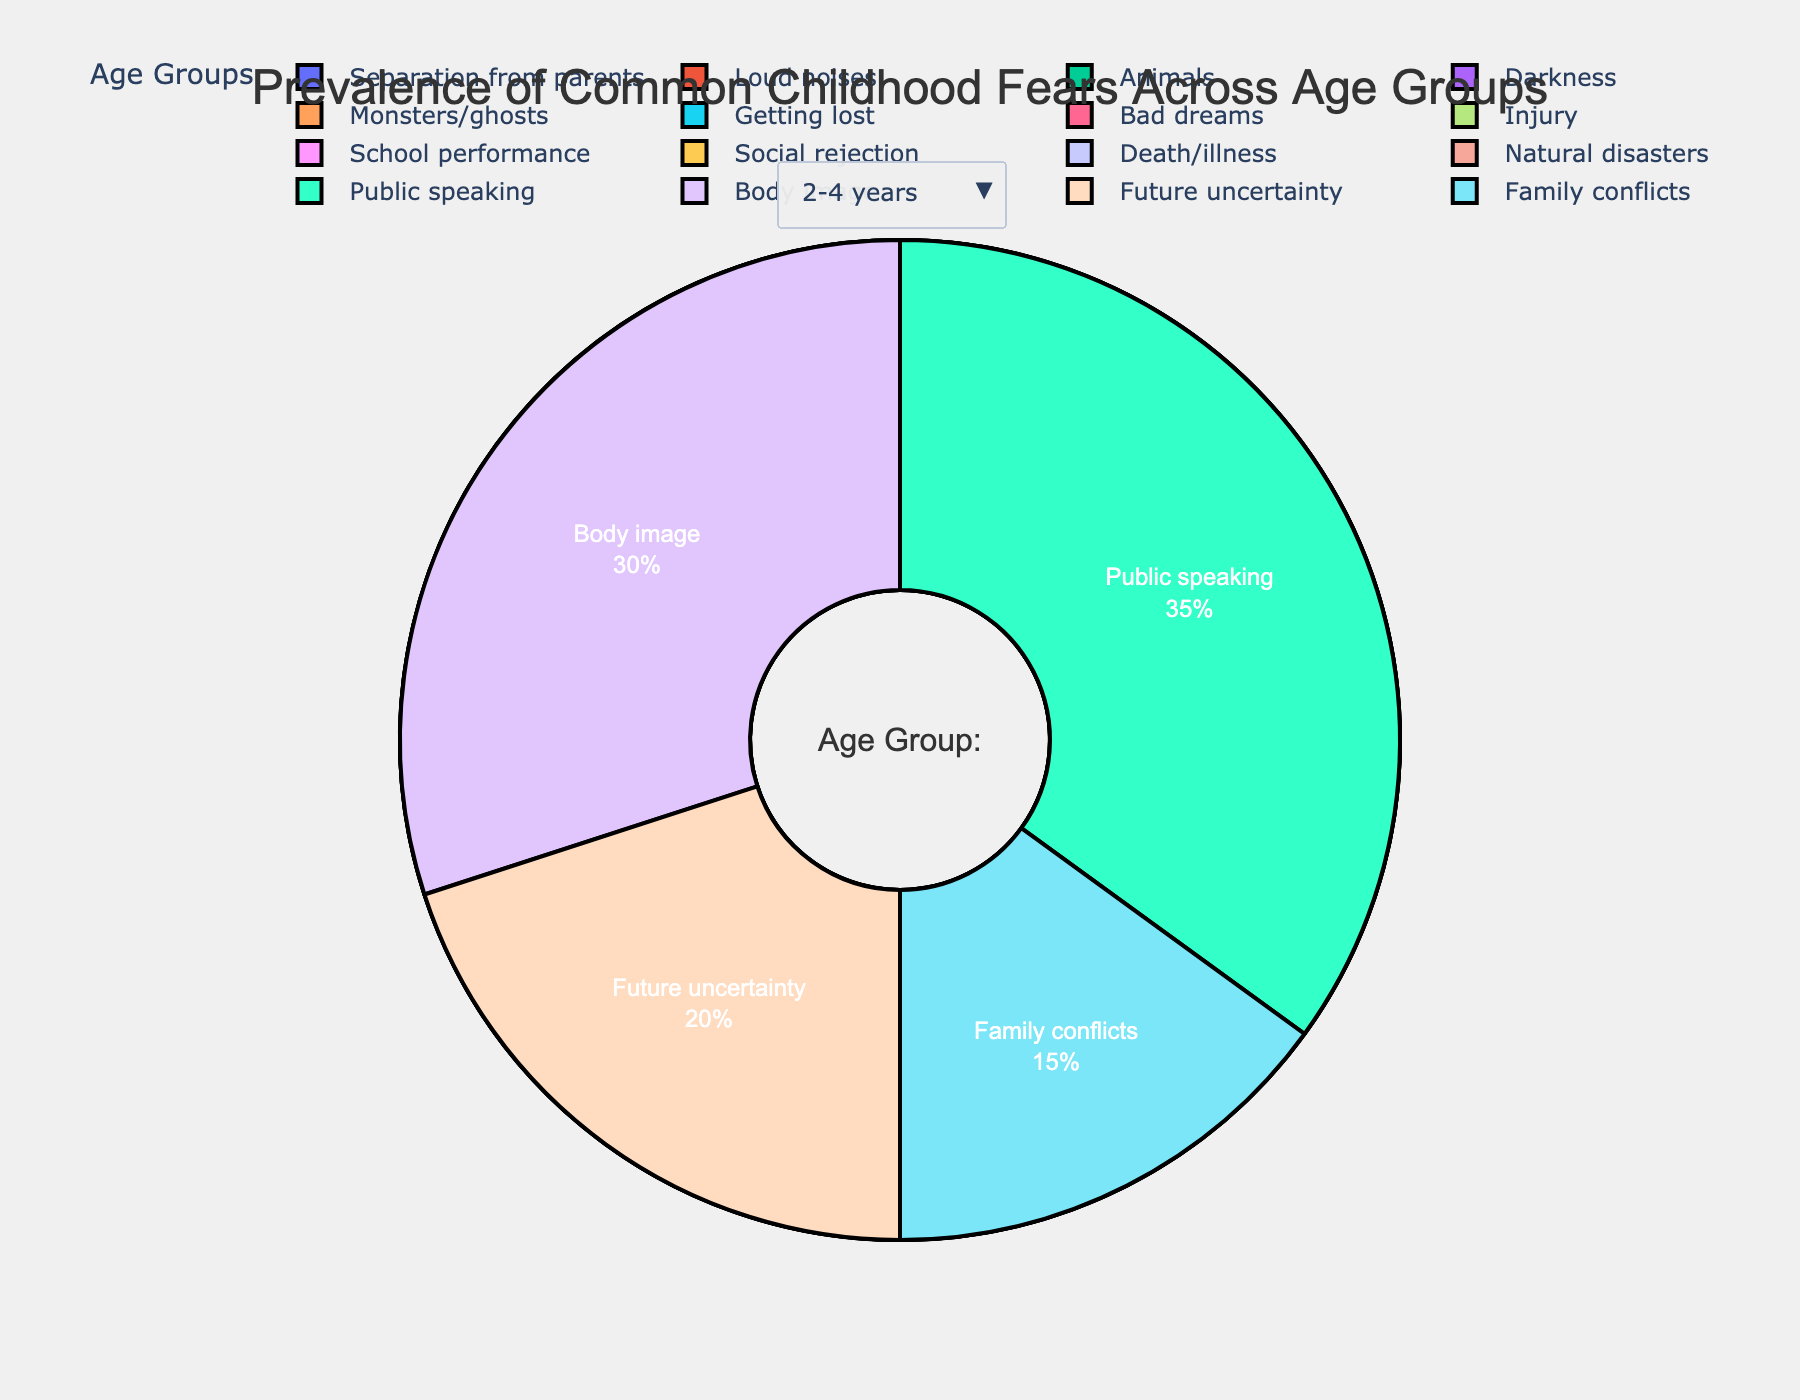What is the most prevalent fear among 2-4 years old children? We look for the biggest segment in the pie chart corresponding to the 2-4 years age group. From the data provided, the largest segment is "Separation from parents" with a prevalence of 35%.
Answer: Separation from parents How does the prevalence of "Public speaking" compare between 12-14 years and 2-4 years age groups? We observe the prevalence percentages of "Public speaking" for both age groups from the pie chart. From the data, "Public speaking" is 35% in the 12-14 years group and is not mentioned for the 2-4 years group. This means it is not a common fear for 2-4 years.
Answer: Higher in 12-14 years What's the combined prevalence of "Monsters/ghosts" and "Bad dreams" for 5-7 years old children? Add the percentages of "Monsters/ghosts" (30%) and "Bad dreams" (25%) from the 5-7 years pie chart. The combined prevalence is 30 + 25.
Answer: 55% Which fear is the least prevalent among the 8-11 years age group? We look for the smallest segment in the pie chart corresponding to the 8-11 years age group, which would be the fear with the lowest prevalence. From the data provided, the smallest segment is "Natural disasters" at 18%.
Answer: Natural disasters Is "Animals" more prevalent in 2-4 years or 5-7 years age groups? By examining the prevalence data for both age groups, we find "Animals" has a prevalence of 22% in the 2-4 years group and it is not mentioned for 5-7 years, meaning it is less prevalent or not a significant fear in that group.
Answer: 2-4 years Compare the prevalence percentages of "Social rejection" and "School performance" among 8-11 years old children. From the data, the prevalence percentage of "Social rejection" is 28% and 32% for "School performance." Comparing these, "School performance" has a higher prevalence.
Answer: School performance is higher Which age group has the highest fear of "Future uncertainty"? We identify the age group with the highest prevalence for "Future uncertainty" by looking at its prevalence across the four age groups. From the provided data, "Future uncertainty" is mentioned only in the 12-14 years group with 20%.
Answer: 12-14 years What is the total prevalence of fears related to "Separation from parents" and "Getting lost" in the dataset? Add the prevalence of "Separation from parents" in the 2-4 years age group (35%) and "Getting lost" in the 5-7 years age group (25%). The total is 35 + 25.
Answer: 60% What is the prevalence difference between "Body image" and "Darkness" fears? Subtract the prevalence of "Darkness" (15%) in the 2-4 years age group from the prevalence of "Body image" (30%) in the 12-14 years age group. The difference is 30 - 15.
Answer: 15% Describe the prevalence of fears related to family and social dynamics for children aged 12-14 years old. Summing the percentage of "Family conflicts" (15%) and adding fears related to social dynamics ("Public speaking" at 35% and "Body image" at 30%) for ages 12-14 based on the data. The total is 15 + 35 + 30.
Answer: 80% 